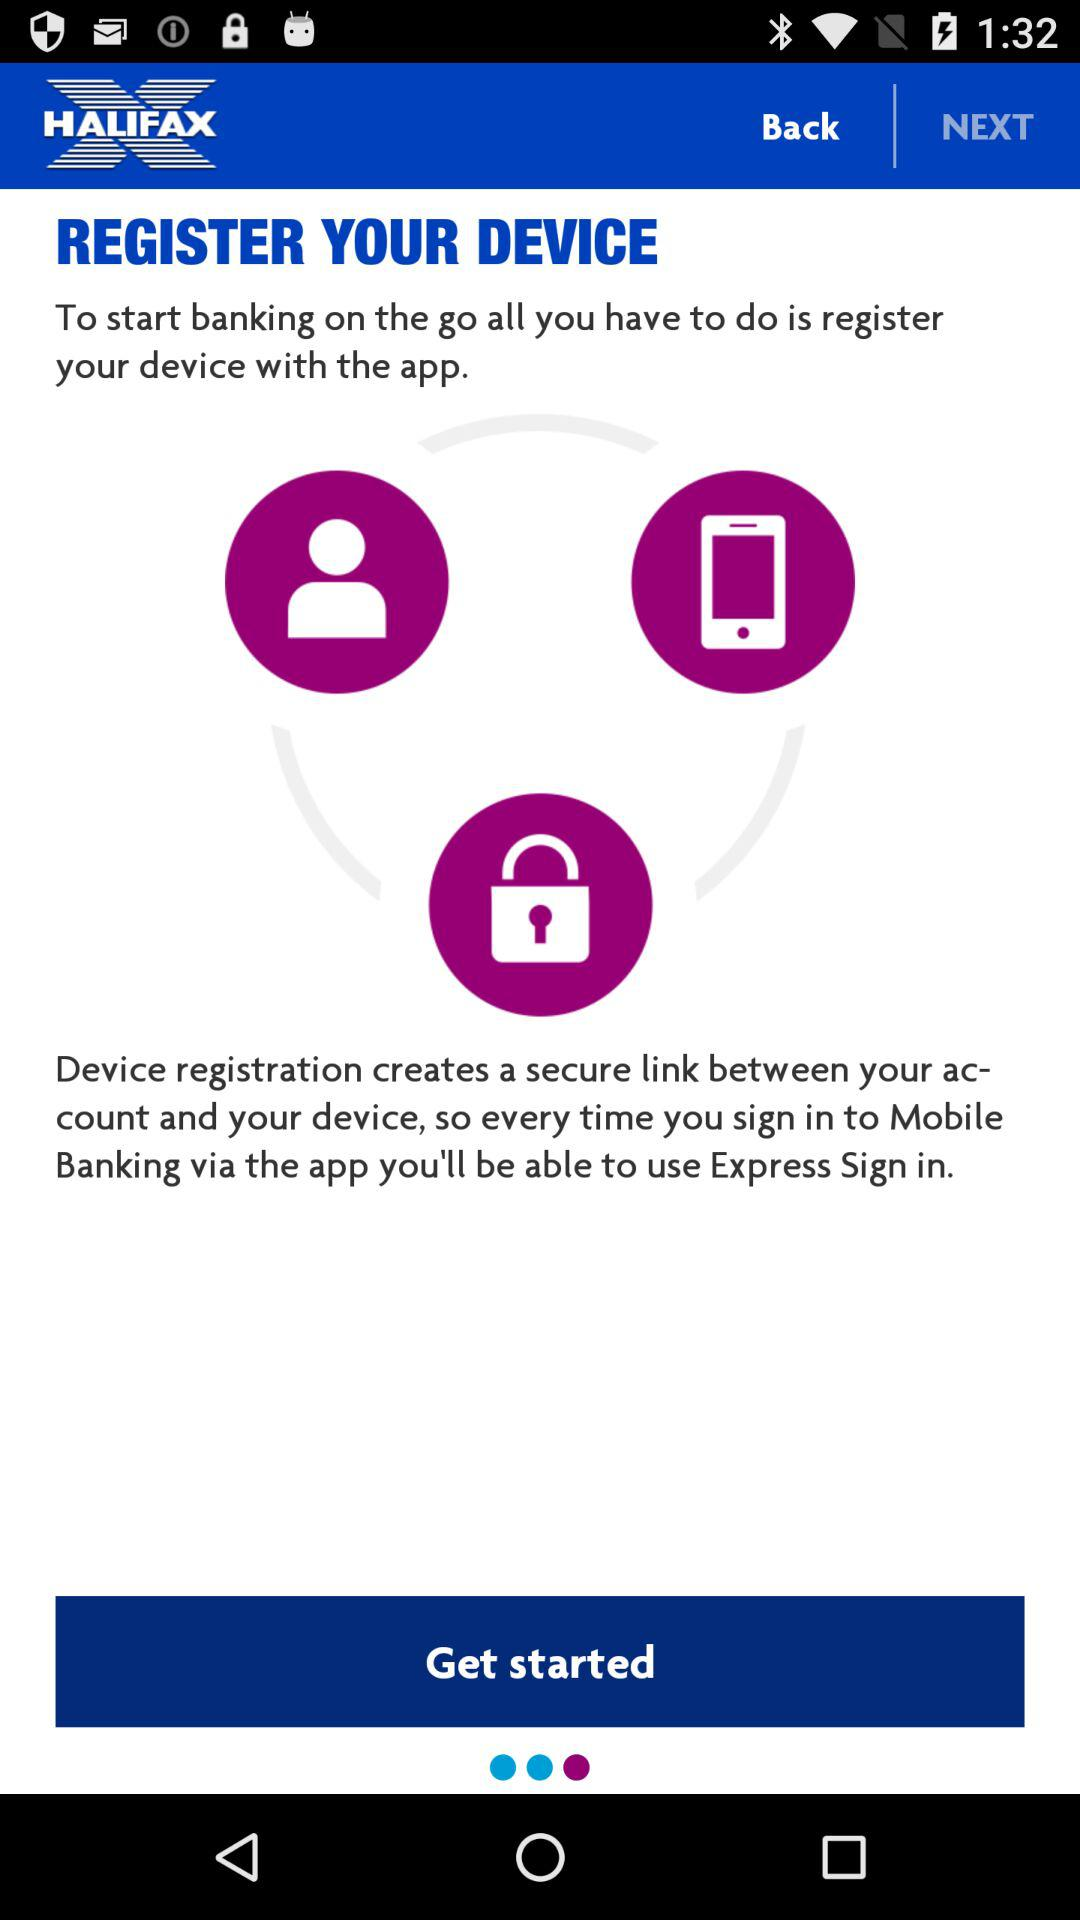What is the name of the application? The application name is "HALIFAX". 